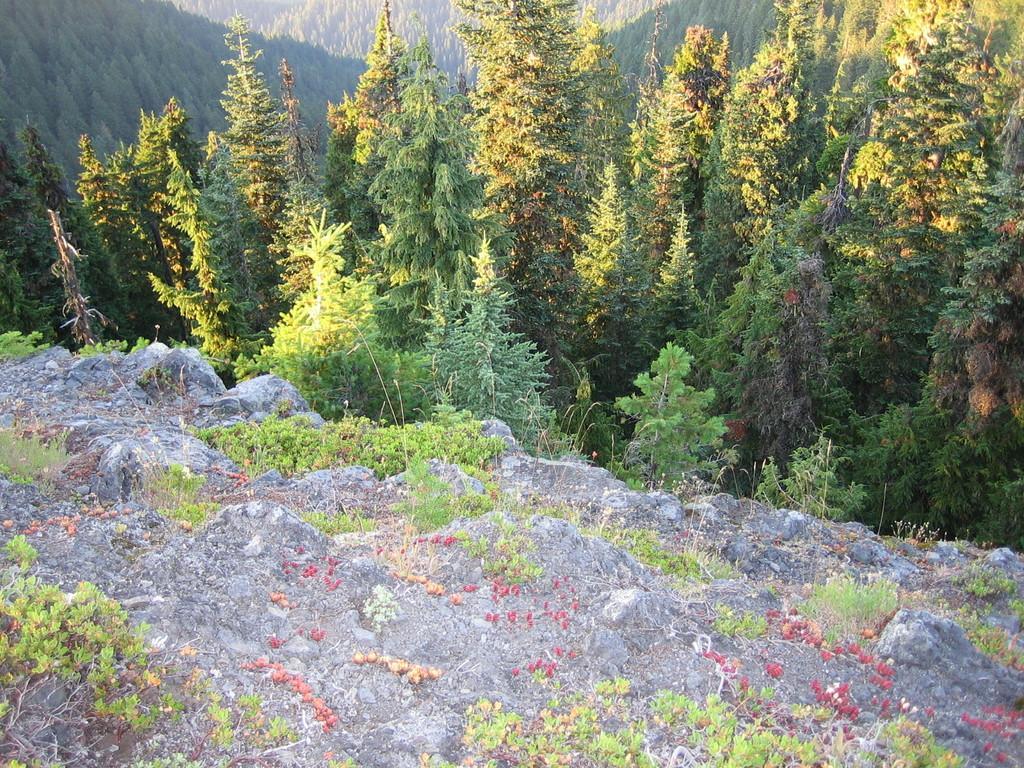How would you summarize this image in a sentence or two? This picture shows trees and we see rock and grass. 